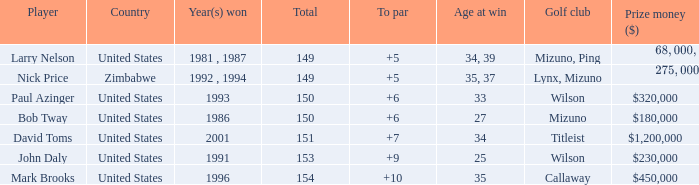Which player won in 1993? Paul Azinger. 